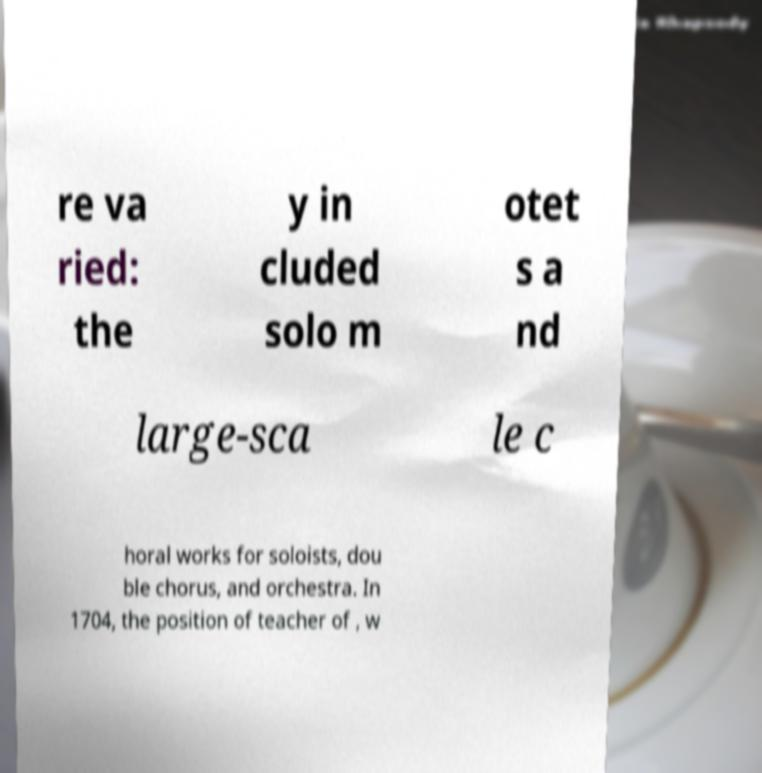For documentation purposes, I need the text within this image transcribed. Could you provide that? re va ried: the y in cluded solo m otet s a nd large-sca le c horal works for soloists, dou ble chorus, and orchestra. In 1704, the position of teacher of , w 